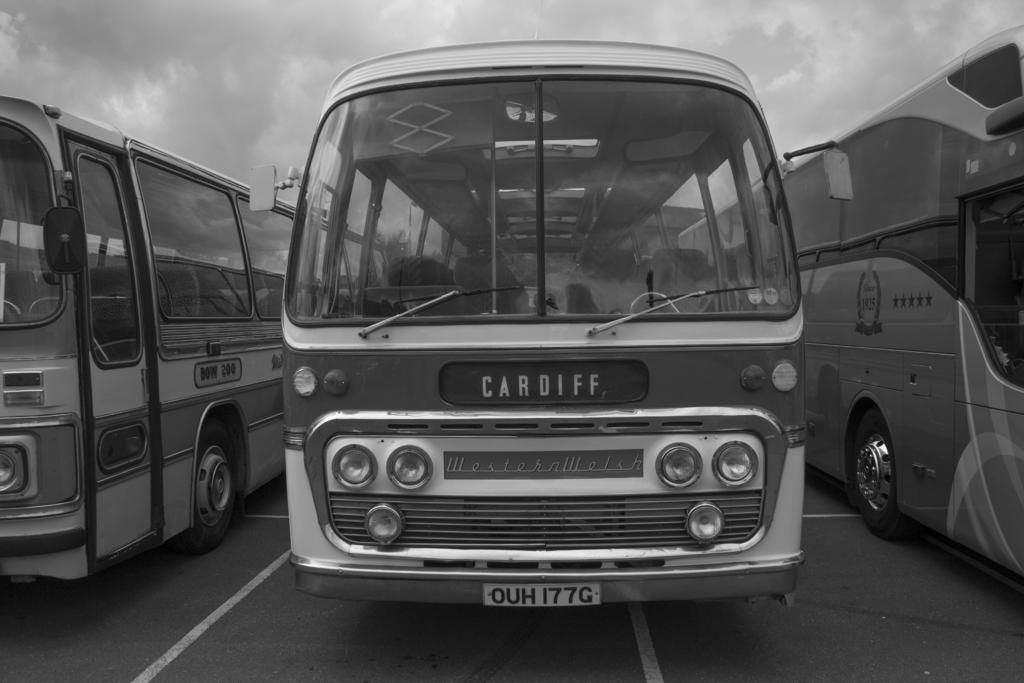Provide a one-sentence caption for the provided image. A black and white photo of three old busses the middle one of which is face on and has Cardiff as its destination. 